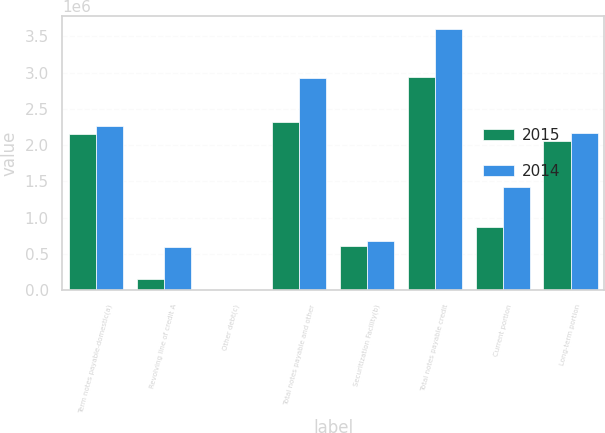<chart> <loc_0><loc_0><loc_500><loc_500><stacked_bar_chart><ecel><fcel>Term notes payable-domestic(a)<fcel>Revolving line of credit A<fcel>Other debt(c)<fcel>Total notes payable and other<fcel>Securitization Facility(b)<fcel>Total notes payable credit<fcel>Current portion<fcel>Long-term portion<nl><fcel>2015<fcel>2.15944e+06<fcel>160000<fcel>3624<fcel>2.32306e+06<fcel>614000<fcel>2.93706e+06<fcel>875647<fcel>2.06142e+06<nl><fcel>2014<fcel>2.261e+06<fcel>595000<fcel>9508<fcel>2.91872e+06<fcel>675000<fcel>3.59372e+06<fcel>1.42476e+06<fcel>2.16895e+06<nl></chart> 